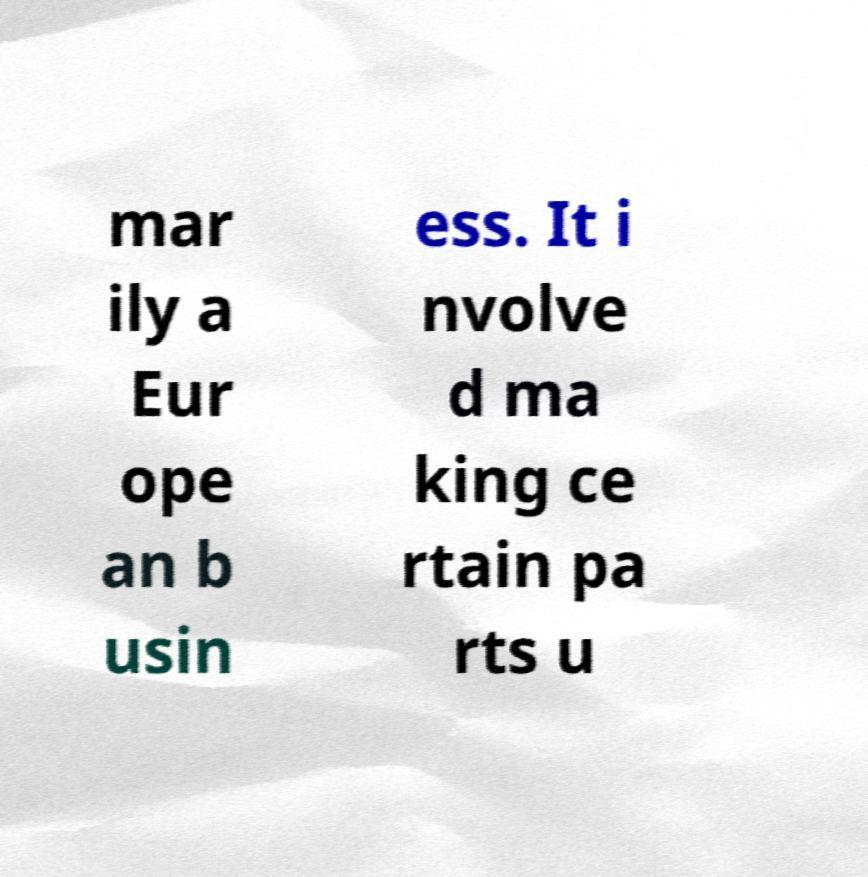Could you assist in decoding the text presented in this image and type it out clearly? mar ily a Eur ope an b usin ess. It i nvolve d ma king ce rtain pa rts u 